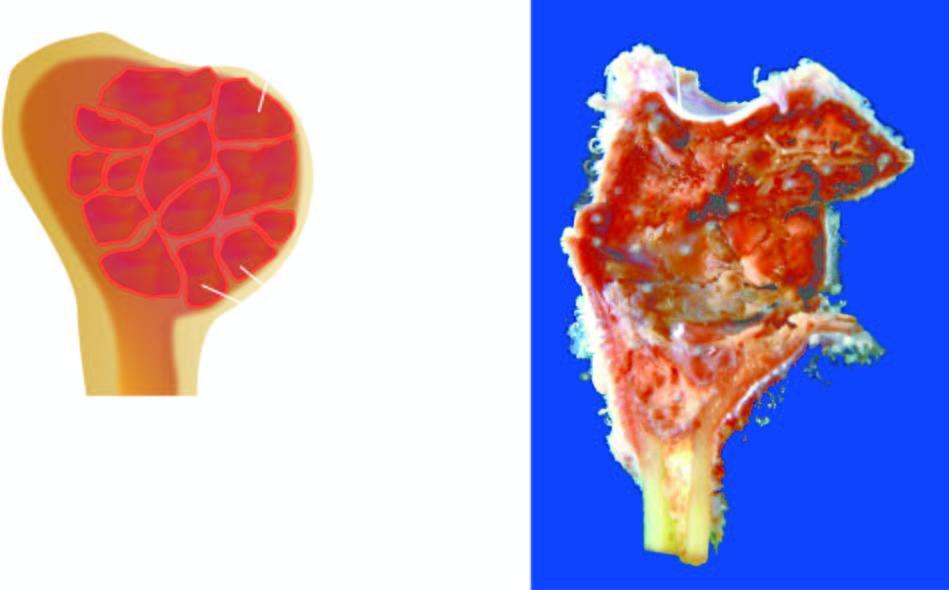what is tan and haemorrhagic?
Answer the question using a single word or phrase. Inner wall of the cyst 